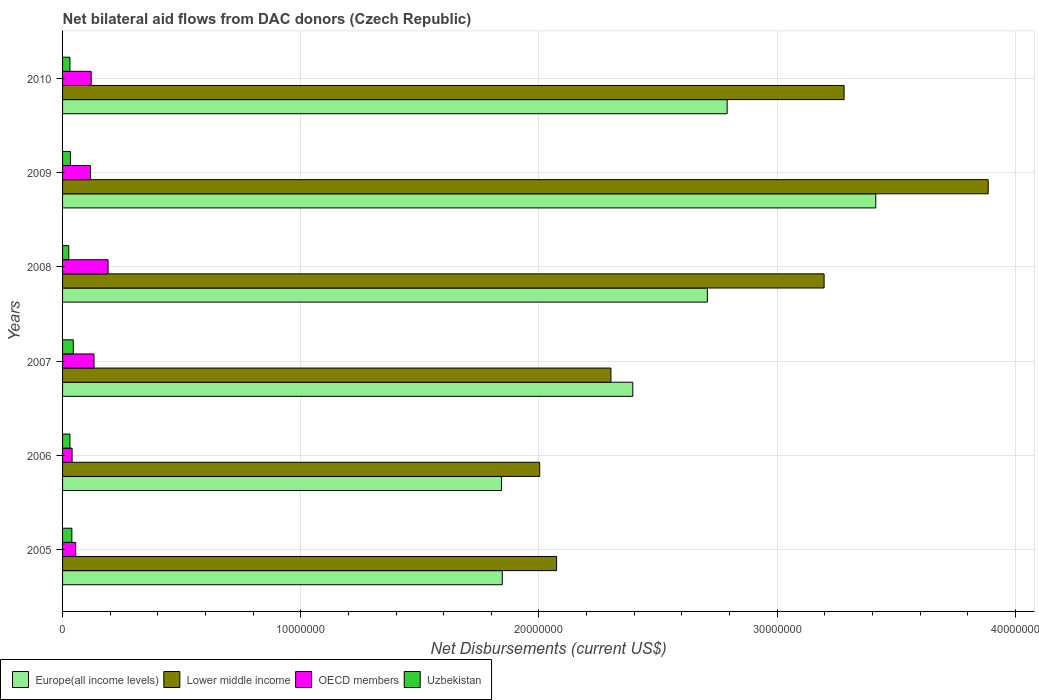How many groups of bars are there?
Make the answer very short. 6. Are the number of bars per tick equal to the number of legend labels?
Make the answer very short. Yes. Are the number of bars on each tick of the Y-axis equal?
Ensure brevity in your answer.  Yes. What is the net bilateral aid flows in Lower middle income in 2005?
Your answer should be compact. 2.07e+07. Across all years, what is the maximum net bilateral aid flows in Europe(all income levels)?
Your response must be concise. 3.41e+07. Across all years, what is the minimum net bilateral aid flows in Uzbekistan?
Give a very brief answer. 2.60e+05. In which year was the net bilateral aid flows in Lower middle income minimum?
Your answer should be compact. 2006. What is the total net bilateral aid flows in Lower middle income in the graph?
Your answer should be compact. 1.67e+08. What is the difference between the net bilateral aid flows in Europe(all income levels) in 2007 and that in 2009?
Keep it short and to the point. -1.02e+07. What is the difference between the net bilateral aid flows in Uzbekistan in 2010 and the net bilateral aid flows in OECD members in 2005?
Provide a short and direct response. -2.40e+05. What is the average net bilateral aid flows in Lower middle income per year?
Make the answer very short. 2.79e+07. In the year 2006, what is the difference between the net bilateral aid flows in Europe(all income levels) and net bilateral aid flows in Uzbekistan?
Offer a very short reply. 1.81e+07. What is the ratio of the net bilateral aid flows in OECD members in 2005 to that in 2006?
Your answer should be compact. 1.38. What is the difference between the highest and the lowest net bilateral aid flows in Europe(all income levels)?
Your answer should be very brief. 1.57e+07. Is it the case that in every year, the sum of the net bilateral aid flows in Europe(all income levels) and net bilateral aid flows in OECD members is greater than the sum of net bilateral aid flows in Uzbekistan and net bilateral aid flows in Lower middle income?
Give a very brief answer. Yes. What does the 3rd bar from the top in 2010 represents?
Your response must be concise. Lower middle income. What does the 1st bar from the bottom in 2009 represents?
Make the answer very short. Europe(all income levels). Is it the case that in every year, the sum of the net bilateral aid flows in Uzbekistan and net bilateral aid flows in Lower middle income is greater than the net bilateral aid flows in OECD members?
Offer a very short reply. Yes. How many bars are there?
Your answer should be very brief. 24. Are all the bars in the graph horizontal?
Offer a terse response. Yes. What is the difference between two consecutive major ticks on the X-axis?
Offer a very short reply. 1.00e+07. Does the graph contain any zero values?
Your answer should be very brief. No. Does the graph contain grids?
Your answer should be compact. Yes. Where does the legend appear in the graph?
Your answer should be compact. Bottom left. How are the legend labels stacked?
Your response must be concise. Horizontal. What is the title of the graph?
Your answer should be compact. Net bilateral aid flows from DAC donors (Czech Republic). What is the label or title of the X-axis?
Keep it short and to the point. Net Disbursements (current US$). What is the Net Disbursements (current US$) in Europe(all income levels) in 2005?
Provide a short and direct response. 1.85e+07. What is the Net Disbursements (current US$) in Lower middle income in 2005?
Your answer should be very brief. 2.07e+07. What is the Net Disbursements (current US$) in Europe(all income levels) in 2006?
Give a very brief answer. 1.84e+07. What is the Net Disbursements (current US$) in Lower middle income in 2006?
Offer a very short reply. 2.00e+07. What is the Net Disbursements (current US$) of OECD members in 2006?
Provide a short and direct response. 4.00e+05. What is the Net Disbursements (current US$) in Uzbekistan in 2006?
Your answer should be compact. 3.10e+05. What is the Net Disbursements (current US$) in Europe(all income levels) in 2007?
Give a very brief answer. 2.39e+07. What is the Net Disbursements (current US$) of Lower middle income in 2007?
Provide a succinct answer. 2.30e+07. What is the Net Disbursements (current US$) of OECD members in 2007?
Make the answer very short. 1.32e+06. What is the Net Disbursements (current US$) in Uzbekistan in 2007?
Offer a terse response. 4.50e+05. What is the Net Disbursements (current US$) of Europe(all income levels) in 2008?
Keep it short and to the point. 2.71e+07. What is the Net Disbursements (current US$) of Lower middle income in 2008?
Your response must be concise. 3.20e+07. What is the Net Disbursements (current US$) of OECD members in 2008?
Offer a very short reply. 1.91e+06. What is the Net Disbursements (current US$) of Europe(all income levels) in 2009?
Your answer should be compact. 3.41e+07. What is the Net Disbursements (current US$) of Lower middle income in 2009?
Provide a short and direct response. 3.89e+07. What is the Net Disbursements (current US$) in OECD members in 2009?
Your answer should be compact. 1.17e+06. What is the Net Disbursements (current US$) of Europe(all income levels) in 2010?
Your response must be concise. 2.79e+07. What is the Net Disbursements (current US$) in Lower middle income in 2010?
Offer a terse response. 3.28e+07. What is the Net Disbursements (current US$) in OECD members in 2010?
Ensure brevity in your answer.  1.20e+06. Across all years, what is the maximum Net Disbursements (current US$) of Europe(all income levels)?
Ensure brevity in your answer.  3.41e+07. Across all years, what is the maximum Net Disbursements (current US$) in Lower middle income?
Provide a short and direct response. 3.89e+07. Across all years, what is the maximum Net Disbursements (current US$) in OECD members?
Ensure brevity in your answer.  1.91e+06. Across all years, what is the minimum Net Disbursements (current US$) of Europe(all income levels)?
Your response must be concise. 1.84e+07. Across all years, what is the minimum Net Disbursements (current US$) of Lower middle income?
Ensure brevity in your answer.  2.00e+07. What is the total Net Disbursements (current US$) in Europe(all income levels) in the graph?
Your answer should be compact. 1.50e+08. What is the total Net Disbursements (current US$) of Lower middle income in the graph?
Ensure brevity in your answer.  1.67e+08. What is the total Net Disbursements (current US$) in OECD members in the graph?
Your answer should be compact. 6.55e+06. What is the total Net Disbursements (current US$) in Uzbekistan in the graph?
Give a very brief answer. 2.05e+06. What is the difference between the Net Disbursements (current US$) in Lower middle income in 2005 and that in 2006?
Keep it short and to the point. 7.10e+05. What is the difference between the Net Disbursements (current US$) in OECD members in 2005 and that in 2006?
Provide a short and direct response. 1.50e+05. What is the difference between the Net Disbursements (current US$) of Uzbekistan in 2005 and that in 2006?
Provide a short and direct response. 8.00e+04. What is the difference between the Net Disbursements (current US$) of Europe(all income levels) in 2005 and that in 2007?
Keep it short and to the point. -5.48e+06. What is the difference between the Net Disbursements (current US$) in Lower middle income in 2005 and that in 2007?
Offer a very short reply. -2.28e+06. What is the difference between the Net Disbursements (current US$) of OECD members in 2005 and that in 2007?
Provide a succinct answer. -7.70e+05. What is the difference between the Net Disbursements (current US$) of Uzbekistan in 2005 and that in 2007?
Provide a succinct answer. -6.00e+04. What is the difference between the Net Disbursements (current US$) of Europe(all income levels) in 2005 and that in 2008?
Your answer should be compact. -8.61e+06. What is the difference between the Net Disbursements (current US$) in Lower middle income in 2005 and that in 2008?
Provide a short and direct response. -1.12e+07. What is the difference between the Net Disbursements (current US$) in OECD members in 2005 and that in 2008?
Your answer should be compact. -1.36e+06. What is the difference between the Net Disbursements (current US$) of Europe(all income levels) in 2005 and that in 2009?
Give a very brief answer. -1.57e+07. What is the difference between the Net Disbursements (current US$) in Lower middle income in 2005 and that in 2009?
Your answer should be very brief. -1.81e+07. What is the difference between the Net Disbursements (current US$) of OECD members in 2005 and that in 2009?
Make the answer very short. -6.20e+05. What is the difference between the Net Disbursements (current US$) of Uzbekistan in 2005 and that in 2009?
Your response must be concise. 6.00e+04. What is the difference between the Net Disbursements (current US$) of Europe(all income levels) in 2005 and that in 2010?
Your answer should be very brief. -9.44e+06. What is the difference between the Net Disbursements (current US$) in Lower middle income in 2005 and that in 2010?
Your response must be concise. -1.21e+07. What is the difference between the Net Disbursements (current US$) of OECD members in 2005 and that in 2010?
Provide a short and direct response. -6.50e+05. What is the difference between the Net Disbursements (current US$) of Uzbekistan in 2005 and that in 2010?
Provide a succinct answer. 8.00e+04. What is the difference between the Net Disbursements (current US$) of Europe(all income levels) in 2006 and that in 2007?
Give a very brief answer. -5.51e+06. What is the difference between the Net Disbursements (current US$) in Lower middle income in 2006 and that in 2007?
Make the answer very short. -2.99e+06. What is the difference between the Net Disbursements (current US$) in OECD members in 2006 and that in 2007?
Provide a succinct answer. -9.20e+05. What is the difference between the Net Disbursements (current US$) of Europe(all income levels) in 2006 and that in 2008?
Your answer should be very brief. -8.64e+06. What is the difference between the Net Disbursements (current US$) of Lower middle income in 2006 and that in 2008?
Your response must be concise. -1.19e+07. What is the difference between the Net Disbursements (current US$) in OECD members in 2006 and that in 2008?
Offer a terse response. -1.51e+06. What is the difference between the Net Disbursements (current US$) in Europe(all income levels) in 2006 and that in 2009?
Keep it short and to the point. -1.57e+07. What is the difference between the Net Disbursements (current US$) in Lower middle income in 2006 and that in 2009?
Provide a short and direct response. -1.88e+07. What is the difference between the Net Disbursements (current US$) in OECD members in 2006 and that in 2009?
Your response must be concise. -7.70e+05. What is the difference between the Net Disbursements (current US$) of Europe(all income levels) in 2006 and that in 2010?
Offer a very short reply. -9.47e+06. What is the difference between the Net Disbursements (current US$) in Lower middle income in 2006 and that in 2010?
Offer a terse response. -1.28e+07. What is the difference between the Net Disbursements (current US$) of OECD members in 2006 and that in 2010?
Give a very brief answer. -8.00e+05. What is the difference between the Net Disbursements (current US$) of Uzbekistan in 2006 and that in 2010?
Make the answer very short. 0. What is the difference between the Net Disbursements (current US$) in Europe(all income levels) in 2007 and that in 2008?
Offer a very short reply. -3.13e+06. What is the difference between the Net Disbursements (current US$) of Lower middle income in 2007 and that in 2008?
Ensure brevity in your answer.  -8.95e+06. What is the difference between the Net Disbursements (current US$) in OECD members in 2007 and that in 2008?
Give a very brief answer. -5.90e+05. What is the difference between the Net Disbursements (current US$) in Europe(all income levels) in 2007 and that in 2009?
Your answer should be compact. -1.02e+07. What is the difference between the Net Disbursements (current US$) in Lower middle income in 2007 and that in 2009?
Provide a succinct answer. -1.58e+07. What is the difference between the Net Disbursements (current US$) of OECD members in 2007 and that in 2009?
Your answer should be compact. 1.50e+05. What is the difference between the Net Disbursements (current US$) of Europe(all income levels) in 2007 and that in 2010?
Ensure brevity in your answer.  -3.96e+06. What is the difference between the Net Disbursements (current US$) of Lower middle income in 2007 and that in 2010?
Make the answer very short. -9.79e+06. What is the difference between the Net Disbursements (current US$) in OECD members in 2007 and that in 2010?
Give a very brief answer. 1.20e+05. What is the difference between the Net Disbursements (current US$) of Europe(all income levels) in 2008 and that in 2009?
Provide a succinct answer. -7.07e+06. What is the difference between the Net Disbursements (current US$) in Lower middle income in 2008 and that in 2009?
Offer a very short reply. -6.89e+06. What is the difference between the Net Disbursements (current US$) of OECD members in 2008 and that in 2009?
Ensure brevity in your answer.  7.40e+05. What is the difference between the Net Disbursements (current US$) in Uzbekistan in 2008 and that in 2009?
Your response must be concise. -7.00e+04. What is the difference between the Net Disbursements (current US$) of Europe(all income levels) in 2008 and that in 2010?
Give a very brief answer. -8.30e+05. What is the difference between the Net Disbursements (current US$) of Lower middle income in 2008 and that in 2010?
Provide a succinct answer. -8.40e+05. What is the difference between the Net Disbursements (current US$) of OECD members in 2008 and that in 2010?
Offer a very short reply. 7.10e+05. What is the difference between the Net Disbursements (current US$) of Europe(all income levels) in 2009 and that in 2010?
Provide a succinct answer. 6.24e+06. What is the difference between the Net Disbursements (current US$) in Lower middle income in 2009 and that in 2010?
Offer a terse response. 6.05e+06. What is the difference between the Net Disbursements (current US$) in OECD members in 2009 and that in 2010?
Keep it short and to the point. -3.00e+04. What is the difference between the Net Disbursements (current US$) in Europe(all income levels) in 2005 and the Net Disbursements (current US$) in Lower middle income in 2006?
Offer a terse response. -1.57e+06. What is the difference between the Net Disbursements (current US$) in Europe(all income levels) in 2005 and the Net Disbursements (current US$) in OECD members in 2006?
Provide a short and direct response. 1.81e+07. What is the difference between the Net Disbursements (current US$) of Europe(all income levels) in 2005 and the Net Disbursements (current US$) of Uzbekistan in 2006?
Your answer should be compact. 1.82e+07. What is the difference between the Net Disbursements (current US$) of Lower middle income in 2005 and the Net Disbursements (current US$) of OECD members in 2006?
Make the answer very short. 2.03e+07. What is the difference between the Net Disbursements (current US$) of Lower middle income in 2005 and the Net Disbursements (current US$) of Uzbekistan in 2006?
Offer a terse response. 2.04e+07. What is the difference between the Net Disbursements (current US$) of Europe(all income levels) in 2005 and the Net Disbursements (current US$) of Lower middle income in 2007?
Your answer should be very brief. -4.56e+06. What is the difference between the Net Disbursements (current US$) in Europe(all income levels) in 2005 and the Net Disbursements (current US$) in OECD members in 2007?
Your answer should be compact. 1.71e+07. What is the difference between the Net Disbursements (current US$) of Europe(all income levels) in 2005 and the Net Disbursements (current US$) of Uzbekistan in 2007?
Keep it short and to the point. 1.80e+07. What is the difference between the Net Disbursements (current US$) in Lower middle income in 2005 and the Net Disbursements (current US$) in OECD members in 2007?
Provide a short and direct response. 1.94e+07. What is the difference between the Net Disbursements (current US$) in Lower middle income in 2005 and the Net Disbursements (current US$) in Uzbekistan in 2007?
Your answer should be compact. 2.03e+07. What is the difference between the Net Disbursements (current US$) in Europe(all income levels) in 2005 and the Net Disbursements (current US$) in Lower middle income in 2008?
Offer a terse response. -1.35e+07. What is the difference between the Net Disbursements (current US$) of Europe(all income levels) in 2005 and the Net Disbursements (current US$) of OECD members in 2008?
Ensure brevity in your answer.  1.66e+07. What is the difference between the Net Disbursements (current US$) in Europe(all income levels) in 2005 and the Net Disbursements (current US$) in Uzbekistan in 2008?
Ensure brevity in your answer.  1.82e+07. What is the difference between the Net Disbursements (current US$) of Lower middle income in 2005 and the Net Disbursements (current US$) of OECD members in 2008?
Keep it short and to the point. 1.88e+07. What is the difference between the Net Disbursements (current US$) in Lower middle income in 2005 and the Net Disbursements (current US$) in Uzbekistan in 2008?
Make the answer very short. 2.05e+07. What is the difference between the Net Disbursements (current US$) of Europe(all income levels) in 2005 and the Net Disbursements (current US$) of Lower middle income in 2009?
Keep it short and to the point. -2.04e+07. What is the difference between the Net Disbursements (current US$) of Europe(all income levels) in 2005 and the Net Disbursements (current US$) of OECD members in 2009?
Provide a succinct answer. 1.73e+07. What is the difference between the Net Disbursements (current US$) in Europe(all income levels) in 2005 and the Net Disbursements (current US$) in Uzbekistan in 2009?
Keep it short and to the point. 1.81e+07. What is the difference between the Net Disbursements (current US$) in Lower middle income in 2005 and the Net Disbursements (current US$) in OECD members in 2009?
Offer a very short reply. 1.96e+07. What is the difference between the Net Disbursements (current US$) in Lower middle income in 2005 and the Net Disbursements (current US$) in Uzbekistan in 2009?
Offer a very short reply. 2.04e+07. What is the difference between the Net Disbursements (current US$) of OECD members in 2005 and the Net Disbursements (current US$) of Uzbekistan in 2009?
Ensure brevity in your answer.  2.20e+05. What is the difference between the Net Disbursements (current US$) of Europe(all income levels) in 2005 and the Net Disbursements (current US$) of Lower middle income in 2010?
Provide a succinct answer. -1.44e+07. What is the difference between the Net Disbursements (current US$) in Europe(all income levels) in 2005 and the Net Disbursements (current US$) in OECD members in 2010?
Provide a short and direct response. 1.73e+07. What is the difference between the Net Disbursements (current US$) of Europe(all income levels) in 2005 and the Net Disbursements (current US$) of Uzbekistan in 2010?
Provide a succinct answer. 1.82e+07. What is the difference between the Net Disbursements (current US$) in Lower middle income in 2005 and the Net Disbursements (current US$) in OECD members in 2010?
Offer a terse response. 1.95e+07. What is the difference between the Net Disbursements (current US$) in Lower middle income in 2005 and the Net Disbursements (current US$) in Uzbekistan in 2010?
Ensure brevity in your answer.  2.04e+07. What is the difference between the Net Disbursements (current US$) in OECD members in 2005 and the Net Disbursements (current US$) in Uzbekistan in 2010?
Ensure brevity in your answer.  2.40e+05. What is the difference between the Net Disbursements (current US$) in Europe(all income levels) in 2006 and the Net Disbursements (current US$) in Lower middle income in 2007?
Your answer should be very brief. -4.59e+06. What is the difference between the Net Disbursements (current US$) in Europe(all income levels) in 2006 and the Net Disbursements (current US$) in OECD members in 2007?
Give a very brief answer. 1.71e+07. What is the difference between the Net Disbursements (current US$) of Europe(all income levels) in 2006 and the Net Disbursements (current US$) of Uzbekistan in 2007?
Provide a short and direct response. 1.80e+07. What is the difference between the Net Disbursements (current US$) in Lower middle income in 2006 and the Net Disbursements (current US$) in OECD members in 2007?
Your answer should be compact. 1.87e+07. What is the difference between the Net Disbursements (current US$) of Lower middle income in 2006 and the Net Disbursements (current US$) of Uzbekistan in 2007?
Your answer should be very brief. 1.96e+07. What is the difference between the Net Disbursements (current US$) of Europe(all income levels) in 2006 and the Net Disbursements (current US$) of Lower middle income in 2008?
Your answer should be very brief. -1.35e+07. What is the difference between the Net Disbursements (current US$) of Europe(all income levels) in 2006 and the Net Disbursements (current US$) of OECD members in 2008?
Your answer should be compact. 1.65e+07. What is the difference between the Net Disbursements (current US$) in Europe(all income levels) in 2006 and the Net Disbursements (current US$) in Uzbekistan in 2008?
Your answer should be very brief. 1.82e+07. What is the difference between the Net Disbursements (current US$) in Lower middle income in 2006 and the Net Disbursements (current US$) in OECD members in 2008?
Provide a succinct answer. 1.81e+07. What is the difference between the Net Disbursements (current US$) of Lower middle income in 2006 and the Net Disbursements (current US$) of Uzbekistan in 2008?
Provide a short and direct response. 1.98e+07. What is the difference between the Net Disbursements (current US$) of Europe(all income levels) in 2006 and the Net Disbursements (current US$) of Lower middle income in 2009?
Your answer should be compact. -2.04e+07. What is the difference between the Net Disbursements (current US$) of Europe(all income levels) in 2006 and the Net Disbursements (current US$) of OECD members in 2009?
Offer a very short reply. 1.73e+07. What is the difference between the Net Disbursements (current US$) in Europe(all income levels) in 2006 and the Net Disbursements (current US$) in Uzbekistan in 2009?
Your answer should be compact. 1.81e+07. What is the difference between the Net Disbursements (current US$) of Lower middle income in 2006 and the Net Disbursements (current US$) of OECD members in 2009?
Your answer should be very brief. 1.89e+07. What is the difference between the Net Disbursements (current US$) in Lower middle income in 2006 and the Net Disbursements (current US$) in Uzbekistan in 2009?
Provide a short and direct response. 1.97e+07. What is the difference between the Net Disbursements (current US$) of OECD members in 2006 and the Net Disbursements (current US$) of Uzbekistan in 2009?
Provide a short and direct response. 7.00e+04. What is the difference between the Net Disbursements (current US$) in Europe(all income levels) in 2006 and the Net Disbursements (current US$) in Lower middle income in 2010?
Ensure brevity in your answer.  -1.44e+07. What is the difference between the Net Disbursements (current US$) of Europe(all income levels) in 2006 and the Net Disbursements (current US$) of OECD members in 2010?
Keep it short and to the point. 1.72e+07. What is the difference between the Net Disbursements (current US$) of Europe(all income levels) in 2006 and the Net Disbursements (current US$) of Uzbekistan in 2010?
Your answer should be very brief. 1.81e+07. What is the difference between the Net Disbursements (current US$) in Lower middle income in 2006 and the Net Disbursements (current US$) in OECD members in 2010?
Offer a terse response. 1.88e+07. What is the difference between the Net Disbursements (current US$) of Lower middle income in 2006 and the Net Disbursements (current US$) of Uzbekistan in 2010?
Give a very brief answer. 1.97e+07. What is the difference between the Net Disbursements (current US$) in OECD members in 2006 and the Net Disbursements (current US$) in Uzbekistan in 2010?
Give a very brief answer. 9.00e+04. What is the difference between the Net Disbursements (current US$) in Europe(all income levels) in 2007 and the Net Disbursements (current US$) in Lower middle income in 2008?
Your response must be concise. -8.03e+06. What is the difference between the Net Disbursements (current US$) in Europe(all income levels) in 2007 and the Net Disbursements (current US$) in OECD members in 2008?
Provide a short and direct response. 2.20e+07. What is the difference between the Net Disbursements (current US$) of Europe(all income levels) in 2007 and the Net Disbursements (current US$) of Uzbekistan in 2008?
Ensure brevity in your answer.  2.37e+07. What is the difference between the Net Disbursements (current US$) of Lower middle income in 2007 and the Net Disbursements (current US$) of OECD members in 2008?
Provide a short and direct response. 2.11e+07. What is the difference between the Net Disbursements (current US$) in Lower middle income in 2007 and the Net Disbursements (current US$) in Uzbekistan in 2008?
Ensure brevity in your answer.  2.28e+07. What is the difference between the Net Disbursements (current US$) in OECD members in 2007 and the Net Disbursements (current US$) in Uzbekistan in 2008?
Offer a terse response. 1.06e+06. What is the difference between the Net Disbursements (current US$) of Europe(all income levels) in 2007 and the Net Disbursements (current US$) of Lower middle income in 2009?
Offer a very short reply. -1.49e+07. What is the difference between the Net Disbursements (current US$) in Europe(all income levels) in 2007 and the Net Disbursements (current US$) in OECD members in 2009?
Offer a very short reply. 2.28e+07. What is the difference between the Net Disbursements (current US$) of Europe(all income levels) in 2007 and the Net Disbursements (current US$) of Uzbekistan in 2009?
Provide a succinct answer. 2.36e+07. What is the difference between the Net Disbursements (current US$) of Lower middle income in 2007 and the Net Disbursements (current US$) of OECD members in 2009?
Your response must be concise. 2.18e+07. What is the difference between the Net Disbursements (current US$) in Lower middle income in 2007 and the Net Disbursements (current US$) in Uzbekistan in 2009?
Offer a very short reply. 2.27e+07. What is the difference between the Net Disbursements (current US$) of OECD members in 2007 and the Net Disbursements (current US$) of Uzbekistan in 2009?
Give a very brief answer. 9.90e+05. What is the difference between the Net Disbursements (current US$) in Europe(all income levels) in 2007 and the Net Disbursements (current US$) in Lower middle income in 2010?
Give a very brief answer. -8.87e+06. What is the difference between the Net Disbursements (current US$) of Europe(all income levels) in 2007 and the Net Disbursements (current US$) of OECD members in 2010?
Make the answer very short. 2.27e+07. What is the difference between the Net Disbursements (current US$) in Europe(all income levels) in 2007 and the Net Disbursements (current US$) in Uzbekistan in 2010?
Provide a short and direct response. 2.36e+07. What is the difference between the Net Disbursements (current US$) in Lower middle income in 2007 and the Net Disbursements (current US$) in OECD members in 2010?
Make the answer very short. 2.18e+07. What is the difference between the Net Disbursements (current US$) in Lower middle income in 2007 and the Net Disbursements (current US$) in Uzbekistan in 2010?
Give a very brief answer. 2.27e+07. What is the difference between the Net Disbursements (current US$) in OECD members in 2007 and the Net Disbursements (current US$) in Uzbekistan in 2010?
Provide a short and direct response. 1.01e+06. What is the difference between the Net Disbursements (current US$) in Europe(all income levels) in 2008 and the Net Disbursements (current US$) in Lower middle income in 2009?
Offer a terse response. -1.18e+07. What is the difference between the Net Disbursements (current US$) in Europe(all income levels) in 2008 and the Net Disbursements (current US$) in OECD members in 2009?
Ensure brevity in your answer.  2.59e+07. What is the difference between the Net Disbursements (current US$) of Europe(all income levels) in 2008 and the Net Disbursements (current US$) of Uzbekistan in 2009?
Offer a terse response. 2.67e+07. What is the difference between the Net Disbursements (current US$) in Lower middle income in 2008 and the Net Disbursements (current US$) in OECD members in 2009?
Offer a very short reply. 3.08e+07. What is the difference between the Net Disbursements (current US$) of Lower middle income in 2008 and the Net Disbursements (current US$) of Uzbekistan in 2009?
Your answer should be compact. 3.16e+07. What is the difference between the Net Disbursements (current US$) of OECD members in 2008 and the Net Disbursements (current US$) of Uzbekistan in 2009?
Give a very brief answer. 1.58e+06. What is the difference between the Net Disbursements (current US$) in Europe(all income levels) in 2008 and the Net Disbursements (current US$) in Lower middle income in 2010?
Give a very brief answer. -5.74e+06. What is the difference between the Net Disbursements (current US$) in Europe(all income levels) in 2008 and the Net Disbursements (current US$) in OECD members in 2010?
Ensure brevity in your answer.  2.59e+07. What is the difference between the Net Disbursements (current US$) in Europe(all income levels) in 2008 and the Net Disbursements (current US$) in Uzbekistan in 2010?
Provide a succinct answer. 2.68e+07. What is the difference between the Net Disbursements (current US$) in Lower middle income in 2008 and the Net Disbursements (current US$) in OECD members in 2010?
Your answer should be very brief. 3.08e+07. What is the difference between the Net Disbursements (current US$) in Lower middle income in 2008 and the Net Disbursements (current US$) in Uzbekistan in 2010?
Provide a short and direct response. 3.17e+07. What is the difference between the Net Disbursements (current US$) of OECD members in 2008 and the Net Disbursements (current US$) of Uzbekistan in 2010?
Your answer should be compact. 1.60e+06. What is the difference between the Net Disbursements (current US$) in Europe(all income levels) in 2009 and the Net Disbursements (current US$) in Lower middle income in 2010?
Your answer should be compact. 1.33e+06. What is the difference between the Net Disbursements (current US$) of Europe(all income levels) in 2009 and the Net Disbursements (current US$) of OECD members in 2010?
Make the answer very short. 3.29e+07. What is the difference between the Net Disbursements (current US$) of Europe(all income levels) in 2009 and the Net Disbursements (current US$) of Uzbekistan in 2010?
Offer a terse response. 3.38e+07. What is the difference between the Net Disbursements (current US$) of Lower middle income in 2009 and the Net Disbursements (current US$) of OECD members in 2010?
Offer a terse response. 3.77e+07. What is the difference between the Net Disbursements (current US$) of Lower middle income in 2009 and the Net Disbursements (current US$) of Uzbekistan in 2010?
Make the answer very short. 3.86e+07. What is the difference between the Net Disbursements (current US$) of OECD members in 2009 and the Net Disbursements (current US$) of Uzbekistan in 2010?
Ensure brevity in your answer.  8.60e+05. What is the average Net Disbursements (current US$) in Europe(all income levels) per year?
Offer a very short reply. 2.50e+07. What is the average Net Disbursements (current US$) of Lower middle income per year?
Your answer should be very brief. 2.79e+07. What is the average Net Disbursements (current US$) of OECD members per year?
Provide a succinct answer. 1.09e+06. What is the average Net Disbursements (current US$) of Uzbekistan per year?
Your response must be concise. 3.42e+05. In the year 2005, what is the difference between the Net Disbursements (current US$) of Europe(all income levels) and Net Disbursements (current US$) of Lower middle income?
Your response must be concise. -2.28e+06. In the year 2005, what is the difference between the Net Disbursements (current US$) in Europe(all income levels) and Net Disbursements (current US$) in OECD members?
Ensure brevity in your answer.  1.79e+07. In the year 2005, what is the difference between the Net Disbursements (current US$) of Europe(all income levels) and Net Disbursements (current US$) of Uzbekistan?
Provide a succinct answer. 1.81e+07. In the year 2005, what is the difference between the Net Disbursements (current US$) in Lower middle income and Net Disbursements (current US$) in OECD members?
Make the answer very short. 2.02e+07. In the year 2005, what is the difference between the Net Disbursements (current US$) of Lower middle income and Net Disbursements (current US$) of Uzbekistan?
Your response must be concise. 2.04e+07. In the year 2005, what is the difference between the Net Disbursements (current US$) of OECD members and Net Disbursements (current US$) of Uzbekistan?
Make the answer very short. 1.60e+05. In the year 2006, what is the difference between the Net Disbursements (current US$) in Europe(all income levels) and Net Disbursements (current US$) in Lower middle income?
Your answer should be compact. -1.60e+06. In the year 2006, what is the difference between the Net Disbursements (current US$) of Europe(all income levels) and Net Disbursements (current US$) of OECD members?
Make the answer very short. 1.80e+07. In the year 2006, what is the difference between the Net Disbursements (current US$) of Europe(all income levels) and Net Disbursements (current US$) of Uzbekistan?
Provide a succinct answer. 1.81e+07. In the year 2006, what is the difference between the Net Disbursements (current US$) in Lower middle income and Net Disbursements (current US$) in OECD members?
Give a very brief answer. 1.96e+07. In the year 2006, what is the difference between the Net Disbursements (current US$) of Lower middle income and Net Disbursements (current US$) of Uzbekistan?
Ensure brevity in your answer.  1.97e+07. In the year 2006, what is the difference between the Net Disbursements (current US$) of OECD members and Net Disbursements (current US$) of Uzbekistan?
Provide a succinct answer. 9.00e+04. In the year 2007, what is the difference between the Net Disbursements (current US$) of Europe(all income levels) and Net Disbursements (current US$) of Lower middle income?
Offer a terse response. 9.20e+05. In the year 2007, what is the difference between the Net Disbursements (current US$) of Europe(all income levels) and Net Disbursements (current US$) of OECD members?
Ensure brevity in your answer.  2.26e+07. In the year 2007, what is the difference between the Net Disbursements (current US$) of Europe(all income levels) and Net Disbursements (current US$) of Uzbekistan?
Your response must be concise. 2.35e+07. In the year 2007, what is the difference between the Net Disbursements (current US$) of Lower middle income and Net Disbursements (current US$) of OECD members?
Make the answer very short. 2.17e+07. In the year 2007, what is the difference between the Net Disbursements (current US$) of Lower middle income and Net Disbursements (current US$) of Uzbekistan?
Provide a succinct answer. 2.26e+07. In the year 2007, what is the difference between the Net Disbursements (current US$) in OECD members and Net Disbursements (current US$) in Uzbekistan?
Make the answer very short. 8.70e+05. In the year 2008, what is the difference between the Net Disbursements (current US$) of Europe(all income levels) and Net Disbursements (current US$) of Lower middle income?
Your response must be concise. -4.90e+06. In the year 2008, what is the difference between the Net Disbursements (current US$) in Europe(all income levels) and Net Disbursements (current US$) in OECD members?
Ensure brevity in your answer.  2.52e+07. In the year 2008, what is the difference between the Net Disbursements (current US$) of Europe(all income levels) and Net Disbursements (current US$) of Uzbekistan?
Your answer should be compact. 2.68e+07. In the year 2008, what is the difference between the Net Disbursements (current US$) in Lower middle income and Net Disbursements (current US$) in OECD members?
Make the answer very short. 3.01e+07. In the year 2008, what is the difference between the Net Disbursements (current US$) of Lower middle income and Net Disbursements (current US$) of Uzbekistan?
Give a very brief answer. 3.17e+07. In the year 2008, what is the difference between the Net Disbursements (current US$) in OECD members and Net Disbursements (current US$) in Uzbekistan?
Your answer should be compact. 1.65e+06. In the year 2009, what is the difference between the Net Disbursements (current US$) of Europe(all income levels) and Net Disbursements (current US$) of Lower middle income?
Provide a succinct answer. -4.72e+06. In the year 2009, what is the difference between the Net Disbursements (current US$) in Europe(all income levels) and Net Disbursements (current US$) in OECD members?
Make the answer very short. 3.30e+07. In the year 2009, what is the difference between the Net Disbursements (current US$) in Europe(all income levels) and Net Disbursements (current US$) in Uzbekistan?
Your answer should be compact. 3.38e+07. In the year 2009, what is the difference between the Net Disbursements (current US$) of Lower middle income and Net Disbursements (current US$) of OECD members?
Offer a very short reply. 3.77e+07. In the year 2009, what is the difference between the Net Disbursements (current US$) of Lower middle income and Net Disbursements (current US$) of Uzbekistan?
Ensure brevity in your answer.  3.85e+07. In the year 2009, what is the difference between the Net Disbursements (current US$) of OECD members and Net Disbursements (current US$) of Uzbekistan?
Your answer should be very brief. 8.40e+05. In the year 2010, what is the difference between the Net Disbursements (current US$) of Europe(all income levels) and Net Disbursements (current US$) of Lower middle income?
Ensure brevity in your answer.  -4.91e+06. In the year 2010, what is the difference between the Net Disbursements (current US$) of Europe(all income levels) and Net Disbursements (current US$) of OECD members?
Make the answer very short. 2.67e+07. In the year 2010, what is the difference between the Net Disbursements (current US$) of Europe(all income levels) and Net Disbursements (current US$) of Uzbekistan?
Offer a terse response. 2.76e+07. In the year 2010, what is the difference between the Net Disbursements (current US$) in Lower middle income and Net Disbursements (current US$) in OECD members?
Provide a succinct answer. 3.16e+07. In the year 2010, what is the difference between the Net Disbursements (current US$) in Lower middle income and Net Disbursements (current US$) in Uzbekistan?
Give a very brief answer. 3.25e+07. In the year 2010, what is the difference between the Net Disbursements (current US$) in OECD members and Net Disbursements (current US$) in Uzbekistan?
Offer a terse response. 8.90e+05. What is the ratio of the Net Disbursements (current US$) of Lower middle income in 2005 to that in 2006?
Provide a short and direct response. 1.04. What is the ratio of the Net Disbursements (current US$) of OECD members in 2005 to that in 2006?
Your answer should be compact. 1.38. What is the ratio of the Net Disbursements (current US$) in Uzbekistan in 2005 to that in 2006?
Keep it short and to the point. 1.26. What is the ratio of the Net Disbursements (current US$) of Europe(all income levels) in 2005 to that in 2007?
Ensure brevity in your answer.  0.77. What is the ratio of the Net Disbursements (current US$) in Lower middle income in 2005 to that in 2007?
Your response must be concise. 0.9. What is the ratio of the Net Disbursements (current US$) in OECD members in 2005 to that in 2007?
Keep it short and to the point. 0.42. What is the ratio of the Net Disbursements (current US$) of Uzbekistan in 2005 to that in 2007?
Provide a short and direct response. 0.87. What is the ratio of the Net Disbursements (current US$) of Europe(all income levels) in 2005 to that in 2008?
Offer a terse response. 0.68. What is the ratio of the Net Disbursements (current US$) of Lower middle income in 2005 to that in 2008?
Offer a very short reply. 0.65. What is the ratio of the Net Disbursements (current US$) of OECD members in 2005 to that in 2008?
Your answer should be compact. 0.29. What is the ratio of the Net Disbursements (current US$) in Europe(all income levels) in 2005 to that in 2009?
Your answer should be very brief. 0.54. What is the ratio of the Net Disbursements (current US$) of Lower middle income in 2005 to that in 2009?
Make the answer very short. 0.53. What is the ratio of the Net Disbursements (current US$) in OECD members in 2005 to that in 2009?
Your answer should be compact. 0.47. What is the ratio of the Net Disbursements (current US$) in Uzbekistan in 2005 to that in 2009?
Make the answer very short. 1.18. What is the ratio of the Net Disbursements (current US$) of Europe(all income levels) in 2005 to that in 2010?
Keep it short and to the point. 0.66. What is the ratio of the Net Disbursements (current US$) of Lower middle income in 2005 to that in 2010?
Offer a terse response. 0.63. What is the ratio of the Net Disbursements (current US$) in OECD members in 2005 to that in 2010?
Your answer should be compact. 0.46. What is the ratio of the Net Disbursements (current US$) of Uzbekistan in 2005 to that in 2010?
Your answer should be compact. 1.26. What is the ratio of the Net Disbursements (current US$) of Europe(all income levels) in 2006 to that in 2007?
Offer a very short reply. 0.77. What is the ratio of the Net Disbursements (current US$) of Lower middle income in 2006 to that in 2007?
Ensure brevity in your answer.  0.87. What is the ratio of the Net Disbursements (current US$) of OECD members in 2006 to that in 2007?
Your response must be concise. 0.3. What is the ratio of the Net Disbursements (current US$) in Uzbekistan in 2006 to that in 2007?
Your answer should be very brief. 0.69. What is the ratio of the Net Disbursements (current US$) of Europe(all income levels) in 2006 to that in 2008?
Provide a short and direct response. 0.68. What is the ratio of the Net Disbursements (current US$) of Lower middle income in 2006 to that in 2008?
Ensure brevity in your answer.  0.63. What is the ratio of the Net Disbursements (current US$) in OECD members in 2006 to that in 2008?
Give a very brief answer. 0.21. What is the ratio of the Net Disbursements (current US$) in Uzbekistan in 2006 to that in 2008?
Your response must be concise. 1.19. What is the ratio of the Net Disbursements (current US$) of Europe(all income levels) in 2006 to that in 2009?
Give a very brief answer. 0.54. What is the ratio of the Net Disbursements (current US$) in Lower middle income in 2006 to that in 2009?
Offer a very short reply. 0.52. What is the ratio of the Net Disbursements (current US$) of OECD members in 2006 to that in 2009?
Your answer should be very brief. 0.34. What is the ratio of the Net Disbursements (current US$) in Uzbekistan in 2006 to that in 2009?
Offer a terse response. 0.94. What is the ratio of the Net Disbursements (current US$) in Europe(all income levels) in 2006 to that in 2010?
Give a very brief answer. 0.66. What is the ratio of the Net Disbursements (current US$) in Lower middle income in 2006 to that in 2010?
Your answer should be very brief. 0.61. What is the ratio of the Net Disbursements (current US$) of OECD members in 2006 to that in 2010?
Offer a terse response. 0.33. What is the ratio of the Net Disbursements (current US$) in Europe(all income levels) in 2007 to that in 2008?
Ensure brevity in your answer.  0.88. What is the ratio of the Net Disbursements (current US$) of Lower middle income in 2007 to that in 2008?
Your answer should be very brief. 0.72. What is the ratio of the Net Disbursements (current US$) of OECD members in 2007 to that in 2008?
Keep it short and to the point. 0.69. What is the ratio of the Net Disbursements (current US$) of Uzbekistan in 2007 to that in 2008?
Provide a short and direct response. 1.73. What is the ratio of the Net Disbursements (current US$) of Europe(all income levels) in 2007 to that in 2009?
Give a very brief answer. 0.7. What is the ratio of the Net Disbursements (current US$) of Lower middle income in 2007 to that in 2009?
Make the answer very short. 0.59. What is the ratio of the Net Disbursements (current US$) of OECD members in 2007 to that in 2009?
Provide a succinct answer. 1.13. What is the ratio of the Net Disbursements (current US$) of Uzbekistan in 2007 to that in 2009?
Your answer should be compact. 1.36. What is the ratio of the Net Disbursements (current US$) in Europe(all income levels) in 2007 to that in 2010?
Offer a very short reply. 0.86. What is the ratio of the Net Disbursements (current US$) of Lower middle income in 2007 to that in 2010?
Your answer should be very brief. 0.7. What is the ratio of the Net Disbursements (current US$) of OECD members in 2007 to that in 2010?
Provide a short and direct response. 1.1. What is the ratio of the Net Disbursements (current US$) in Uzbekistan in 2007 to that in 2010?
Your response must be concise. 1.45. What is the ratio of the Net Disbursements (current US$) of Europe(all income levels) in 2008 to that in 2009?
Ensure brevity in your answer.  0.79. What is the ratio of the Net Disbursements (current US$) of Lower middle income in 2008 to that in 2009?
Your response must be concise. 0.82. What is the ratio of the Net Disbursements (current US$) in OECD members in 2008 to that in 2009?
Your answer should be compact. 1.63. What is the ratio of the Net Disbursements (current US$) of Uzbekistan in 2008 to that in 2009?
Offer a terse response. 0.79. What is the ratio of the Net Disbursements (current US$) of Europe(all income levels) in 2008 to that in 2010?
Your response must be concise. 0.97. What is the ratio of the Net Disbursements (current US$) in Lower middle income in 2008 to that in 2010?
Your answer should be very brief. 0.97. What is the ratio of the Net Disbursements (current US$) in OECD members in 2008 to that in 2010?
Offer a terse response. 1.59. What is the ratio of the Net Disbursements (current US$) in Uzbekistan in 2008 to that in 2010?
Provide a short and direct response. 0.84. What is the ratio of the Net Disbursements (current US$) in Europe(all income levels) in 2009 to that in 2010?
Provide a short and direct response. 1.22. What is the ratio of the Net Disbursements (current US$) in Lower middle income in 2009 to that in 2010?
Keep it short and to the point. 1.18. What is the ratio of the Net Disbursements (current US$) of Uzbekistan in 2009 to that in 2010?
Offer a terse response. 1.06. What is the difference between the highest and the second highest Net Disbursements (current US$) in Europe(all income levels)?
Offer a terse response. 6.24e+06. What is the difference between the highest and the second highest Net Disbursements (current US$) of Lower middle income?
Give a very brief answer. 6.05e+06. What is the difference between the highest and the second highest Net Disbursements (current US$) of OECD members?
Offer a terse response. 5.90e+05. What is the difference between the highest and the second highest Net Disbursements (current US$) in Uzbekistan?
Ensure brevity in your answer.  6.00e+04. What is the difference between the highest and the lowest Net Disbursements (current US$) in Europe(all income levels)?
Make the answer very short. 1.57e+07. What is the difference between the highest and the lowest Net Disbursements (current US$) in Lower middle income?
Provide a succinct answer. 1.88e+07. What is the difference between the highest and the lowest Net Disbursements (current US$) of OECD members?
Keep it short and to the point. 1.51e+06. 